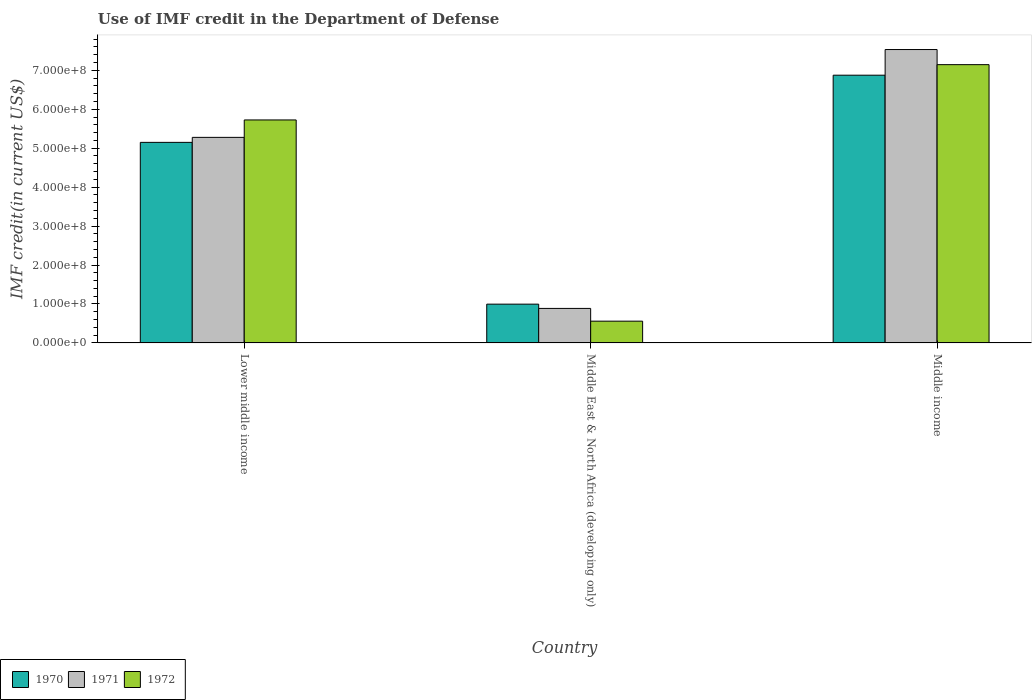How many groups of bars are there?
Provide a succinct answer. 3. Are the number of bars per tick equal to the number of legend labels?
Your answer should be compact. Yes. How many bars are there on the 1st tick from the left?
Your response must be concise. 3. What is the label of the 3rd group of bars from the left?
Your answer should be very brief. Middle income. What is the IMF credit in the Department of Defense in 1970 in Middle income?
Provide a short and direct response. 6.87e+08. Across all countries, what is the maximum IMF credit in the Department of Defense in 1970?
Give a very brief answer. 6.87e+08. Across all countries, what is the minimum IMF credit in the Department of Defense in 1970?
Your answer should be very brief. 9.96e+07. In which country was the IMF credit in the Department of Defense in 1971 maximum?
Your answer should be very brief. Middle income. In which country was the IMF credit in the Department of Defense in 1972 minimum?
Provide a short and direct response. Middle East & North Africa (developing only). What is the total IMF credit in the Department of Defense in 1972 in the graph?
Offer a terse response. 1.34e+09. What is the difference between the IMF credit in the Department of Defense in 1970 in Middle East & North Africa (developing only) and that in Middle income?
Provide a short and direct response. -5.88e+08. What is the difference between the IMF credit in the Department of Defense in 1972 in Lower middle income and the IMF credit in the Department of Defense in 1970 in Middle income?
Offer a very short reply. -1.15e+08. What is the average IMF credit in the Department of Defense in 1972 per country?
Your answer should be compact. 4.48e+08. What is the difference between the IMF credit in the Department of Defense of/in 1970 and IMF credit in the Department of Defense of/in 1971 in Middle East & North Africa (developing only)?
Offer a very short reply. 1.10e+07. In how many countries, is the IMF credit in the Department of Defense in 1971 greater than 40000000 US$?
Your answer should be compact. 3. What is the ratio of the IMF credit in the Department of Defense in 1970 in Middle East & North Africa (developing only) to that in Middle income?
Offer a very short reply. 0.14. Is the IMF credit in the Department of Defense in 1972 in Lower middle income less than that in Middle income?
Your answer should be very brief. Yes. What is the difference between the highest and the second highest IMF credit in the Department of Defense in 1970?
Your answer should be compact. 5.88e+08. What is the difference between the highest and the lowest IMF credit in the Department of Defense in 1972?
Provide a short and direct response. 6.59e+08. Is the sum of the IMF credit in the Department of Defense in 1971 in Lower middle income and Middle income greater than the maximum IMF credit in the Department of Defense in 1970 across all countries?
Provide a short and direct response. Yes. What does the 3rd bar from the right in Middle East & North Africa (developing only) represents?
Your answer should be compact. 1970. Is it the case that in every country, the sum of the IMF credit in the Department of Defense in 1970 and IMF credit in the Department of Defense in 1971 is greater than the IMF credit in the Department of Defense in 1972?
Provide a succinct answer. Yes. How many bars are there?
Ensure brevity in your answer.  9. How many countries are there in the graph?
Offer a terse response. 3. Does the graph contain any zero values?
Your answer should be very brief. No. Does the graph contain grids?
Offer a terse response. No. How are the legend labels stacked?
Give a very brief answer. Horizontal. What is the title of the graph?
Provide a short and direct response. Use of IMF credit in the Department of Defense. What is the label or title of the X-axis?
Offer a very short reply. Country. What is the label or title of the Y-axis?
Offer a terse response. IMF credit(in current US$). What is the IMF credit(in current US$) of 1970 in Lower middle income?
Your answer should be compact. 5.15e+08. What is the IMF credit(in current US$) of 1971 in Lower middle income?
Your answer should be compact. 5.28e+08. What is the IMF credit(in current US$) of 1972 in Lower middle income?
Offer a terse response. 5.73e+08. What is the IMF credit(in current US$) of 1970 in Middle East & North Africa (developing only)?
Your response must be concise. 9.96e+07. What is the IMF credit(in current US$) in 1971 in Middle East & North Africa (developing only)?
Provide a short and direct response. 8.86e+07. What is the IMF credit(in current US$) of 1972 in Middle East & North Africa (developing only)?
Provide a succinct answer. 5.59e+07. What is the IMF credit(in current US$) in 1970 in Middle income?
Your answer should be very brief. 6.87e+08. What is the IMF credit(in current US$) of 1971 in Middle income?
Your answer should be very brief. 7.53e+08. What is the IMF credit(in current US$) of 1972 in Middle income?
Offer a very short reply. 7.14e+08. Across all countries, what is the maximum IMF credit(in current US$) of 1970?
Ensure brevity in your answer.  6.87e+08. Across all countries, what is the maximum IMF credit(in current US$) of 1971?
Provide a succinct answer. 7.53e+08. Across all countries, what is the maximum IMF credit(in current US$) of 1972?
Give a very brief answer. 7.14e+08. Across all countries, what is the minimum IMF credit(in current US$) of 1970?
Offer a very short reply. 9.96e+07. Across all countries, what is the minimum IMF credit(in current US$) of 1971?
Ensure brevity in your answer.  8.86e+07. Across all countries, what is the minimum IMF credit(in current US$) of 1972?
Your response must be concise. 5.59e+07. What is the total IMF credit(in current US$) of 1970 in the graph?
Offer a terse response. 1.30e+09. What is the total IMF credit(in current US$) in 1971 in the graph?
Offer a terse response. 1.37e+09. What is the total IMF credit(in current US$) in 1972 in the graph?
Offer a very short reply. 1.34e+09. What is the difference between the IMF credit(in current US$) in 1970 in Lower middle income and that in Middle East & North Africa (developing only)?
Offer a very short reply. 4.15e+08. What is the difference between the IMF credit(in current US$) of 1971 in Lower middle income and that in Middle East & North Africa (developing only)?
Ensure brevity in your answer.  4.39e+08. What is the difference between the IMF credit(in current US$) in 1972 in Lower middle income and that in Middle East & North Africa (developing only)?
Your response must be concise. 5.17e+08. What is the difference between the IMF credit(in current US$) in 1970 in Lower middle income and that in Middle income?
Your answer should be very brief. -1.72e+08. What is the difference between the IMF credit(in current US$) in 1971 in Lower middle income and that in Middle income?
Provide a succinct answer. -2.25e+08. What is the difference between the IMF credit(in current US$) of 1972 in Lower middle income and that in Middle income?
Provide a short and direct response. -1.42e+08. What is the difference between the IMF credit(in current US$) in 1970 in Middle East & North Africa (developing only) and that in Middle income?
Your answer should be very brief. -5.88e+08. What is the difference between the IMF credit(in current US$) in 1971 in Middle East & North Africa (developing only) and that in Middle income?
Give a very brief answer. -6.65e+08. What is the difference between the IMF credit(in current US$) in 1972 in Middle East & North Africa (developing only) and that in Middle income?
Ensure brevity in your answer.  -6.59e+08. What is the difference between the IMF credit(in current US$) of 1970 in Lower middle income and the IMF credit(in current US$) of 1971 in Middle East & North Africa (developing only)?
Provide a succinct answer. 4.26e+08. What is the difference between the IMF credit(in current US$) in 1970 in Lower middle income and the IMF credit(in current US$) in 1972 in Middle East & North Africa (developing only)?
Offer a very short reply. 4.59e+08. What is the difference between the IMF credit(in current US$) of 1971 in Lower middle income and the IMF credit(in current US$) of 1972 in Middle East & North Africa (developing only)?
Your answer should be compact. 4.72e+08. What is the difference between the IMF credit(in current US$) in 1970 in Lower middle income and the IMF credit(in current US$) in 1971 in Middle income?
Your answer should be very brief. -2.38e+08. What is the difference between the IMF credit(in current US$) of 1970 in Lower middle income and the IMF credit(in current US$) of 1972 in Middle income?
Provide a short and direct response. -2.00e+08. What is the difference between the IMF credit(in current US$) in 1971 in Lower middle income and the IMF credit(in current US$) in 1972 in Middle income?
Make the answer very short. -1.87e+08. What is the difference between the IMF credit(in current US$) of 1970 in Middle East & North Africa (developing only) and the IMF credit(in current US$) of 1971 in Middle income?
Your answer should be compact. -6.54e+08. What is the difference between the IMF credit(in current US$) of 1970 in Middle East & North Africa (developing only) and the IMF credit(in current US$) of 1972 in Middle income?
Provide a succinct answer. -6.15e+08. What is the difference between the IMF credit(in current US$) of 1971 in Middle East & North Africa (developing only) and the IMF credit(in current US$) of 1972 in Middle income?
Make the answer very short. -6.26e+08. What is the average IMF credit(in current US$) in 1970 per country?
Your response must be concise. 4.34e+08. What is the average IMF credit(in current US$) of 1971 per country?
Provide a succinct answer. 4.57e+08. What is the average IMF credit(in current US$) of 1972 per country?
Give a very brief answer. 4.48e+08. What is the difference between the IMF credit(in current US$) in 1970 and IMF credit(in current US$) in 1971 in Lower middle income?
Give a very brief answer. -1.28e+07. What is the difference between the IMF credit(in current US$) in 1970 and IMF credit(in current US$) in 1972 in Lower middle income?
Your response must be concise. -5.76e+07. What is the difference between the IMF credit(in current US$) in 1971 and IMF credit(in current US$) in 1972 in Lower middle income?
Provide a short and direct response. -4.48e+07. What is the difference between the IMF credit(in current US$) in 1970 and IMF credit(in current US$) in 1971 in Middle East & North Africa (developing only)?
Keep it short and to the point. 1.10e+07. What is the difference between the IMF credit(in current US$) in 1970 and IMF credit(in current US$) in 1972 in Middle East & North Africa (developing only)?
Offer a very short reply. 4.37e+07. What is the difference between the IMF credit(in current US$) of 1971 and IMF credit(in current US$) of 1972 in Middle East & North Africa (developing only)?
Keep it short and to the point. 3.27e+07. What is the difference between the IMF credit(in current US$) in 1970 and IMF credit(in current US$) in 1971 in Middle income?
Keep it short and to the point. -6.58e+07. What is the difference between the IMF credit(in current US$) in 1970 and IMF credit(in current US$) in 1972 in Middle income?
Your answer should be compact. -2.71e+07. What is the difference between the IMF credit(in current US$) of 1971 and IMF credit(in current US$) of 1972 in Middle income?
Your response must be concise. 3.88e+07. What is the ratio of the IMF credit(in current US$) in 1970 in Lower middle income to that in Middle East & North Africa (developing only)?
Offer a very short reply. 5.17. What is the ratio of the IMF credit(in current US$) of 1971 in Lower middle income to that in Middle East & North Africa (developing only)?
Your answer should be very brief. 5.95. What is the ratio of the IMF credit(in current US$) in 1972 in Lower middle income to that in Middle East & North Africa (developing only)?
Offer a very short reply. 10.24. What is the ratio of the IMF credit(in current US$) in 1970 in Lower middle income to that in Middle income?
Ensure brevity in your answer.  0.75. What is the ratio of the IMF credit(in current US$) of 1971 in Lower middle income to that in Middle income?
Your answer should be compact. 0.7. What is the ratio of the IMF credit(in current US$) of 1972 in Lower middle income to that in Middle income?
Ensure brevity in your answer.  0.8. What is the ratio of the IMF credit(in current US$) in 1970 in Middle East & North Africa (developing only) to that in Middle income?
Your answer should be compact. 0.14. What is the ratio of the IMF credit(in current US$) of 1971 in Middle East & North Africa (developing only) to that in Middle income?
Keep it short and to the point. 0.12. What is the ratio of the IMF credit(in current US$) in 1972 in Middle East & North Africa (developing only) to that in Middle income?
Your answer should be compact. 0.08. What is the difference between the highest and the second highest IMF credit(in current US$) of 1970?
Your answer should be very brief. 1.72e+08. What is the difference between the highest and the second highest IMF credit(in current US$) of 1971?
Keep it short and to the point. 2.25e+08. What is the difference between the highest and the second highest IMF credit(in current US$) in 1972?
Your answer should be compact. 1.42e+08. What is the difference between the highest and the lowest IMF credit(in current US$) in 1970?
Provide a short and direct response. 5.88e+08. What is the difference between the highest and the lowest IMF credit(in current US$) of 1971?
Offer a very short reply. 6.65e+08. What is the difference between the highest and the lowest IMF credit(in current US$) of 1972?
Your answer should be compact. 6.59e+08. 